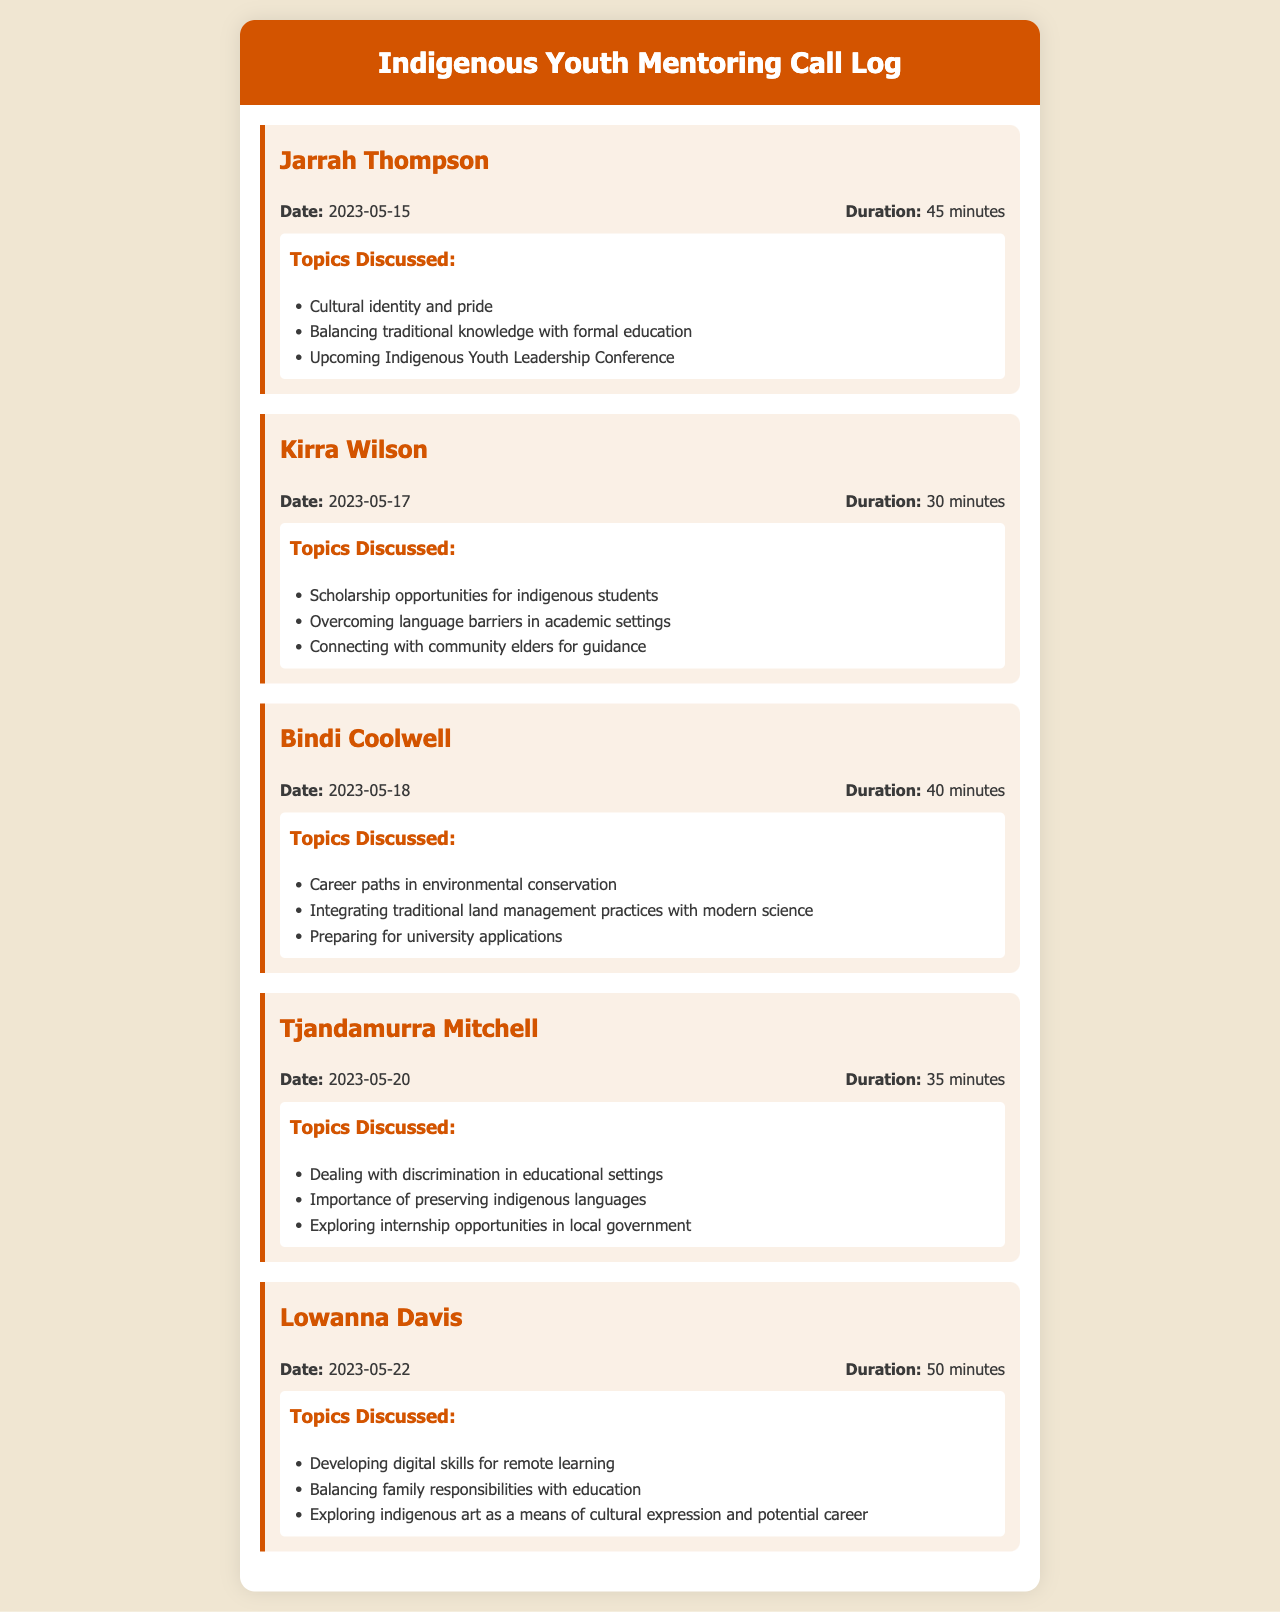what is the duration of the call with Jarrah Thompson? The duration is stated clearly in the call log entry for Jarrah Thompson.
Answer: 45 minutes what are the topics discussed with Kirra Wilson? The topics discussed can be found in the list under the call entry for Kirra Wilson.
Answer: Scholarship opportunities for indigenous students, overcoming language barriers in academic settings, connecting with community elders for guidance on what date did Tjandamurra Mitchell's call take place? The date of the call is included in the call details for Tjandamurra Mitchell.
Answer: 2023-05-20 who was the last person to have a mentoring call recorded? The last call entry in the document indicates the person with the most recent call.
Answer: Lowanna Davis how many minutes was Bindi Coolwell's call? The duration is listed in the call details for Bindi Coolwell.
Answer: 40 minutes which topics were discussed during the call with Lowanna Davis? The topics discussed are presented in a list format under the call entry for Lowanna Davis.
Answer: Developing digital skills for remote learning, balancing family responsibilities with education, exploring indigenous art as a means of cultural expression and potential career what call entry comes before Kirra Wilson in the document? The call entries are sequenced by date, so the entry preceding Kirra Wilson provides this information.
Answer: Jarrah Thompson how many total calls are logged in this document? The total number of call entries can be counted directly from the individual entries presented in the document.
Answer: 5 